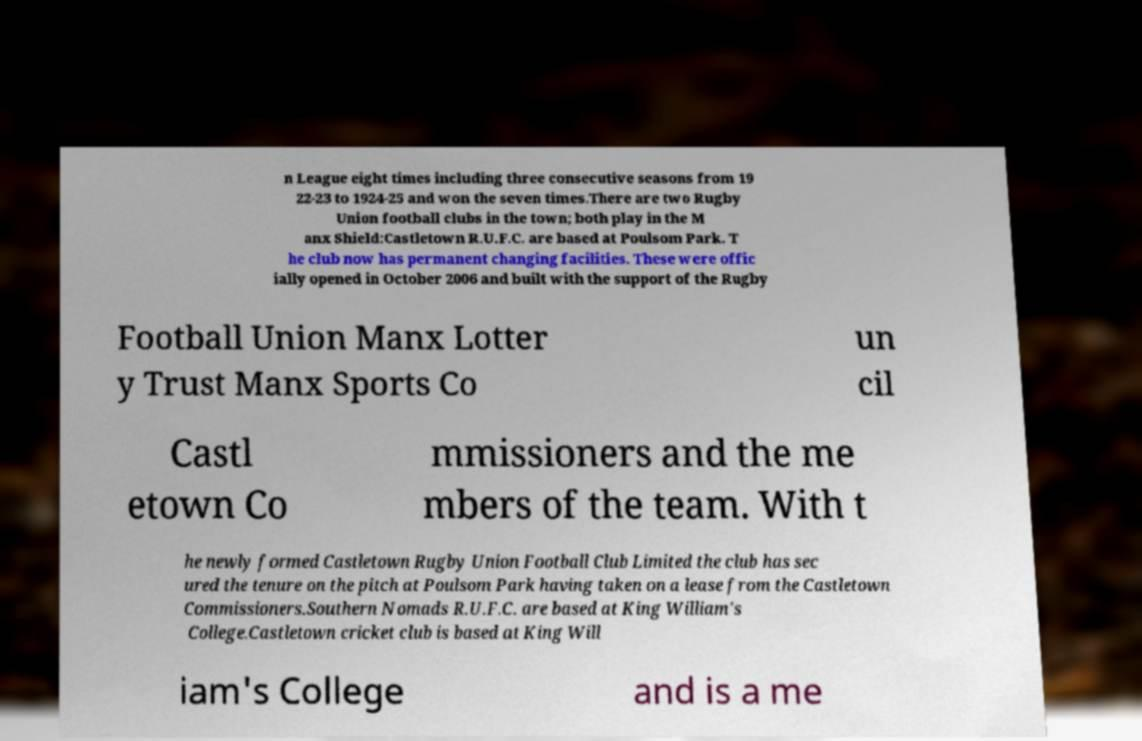I need the written content from this picture converted into text. Can you do that? n League eight times including three consecutive seasons from 19 22-23 to 1924-25 and won the seven times.There are two Rugby Union football clubs in the town; both play in the M anx Shield:Castletown R.U.F.C. are based at Poulsom Park. T he club now has permanent changing facilities. These were offic ially opened in October 2006 and built with the support of the Rugby Football Union Manx Lotter y Trust Manx Sports Co un cil Castl etown Co mmissioners and the me mbers of the team. With t he newly formed Castletown Rugby Union Football Club Limited the club has sec ured the tenure on the pitch at Poulsom Park having taken on a lease from the Castletown Commissioners.Southern Nomads R.U.F.C. are based at King William's College.Castletown cricket club is based at King Will iam's College and is a me 